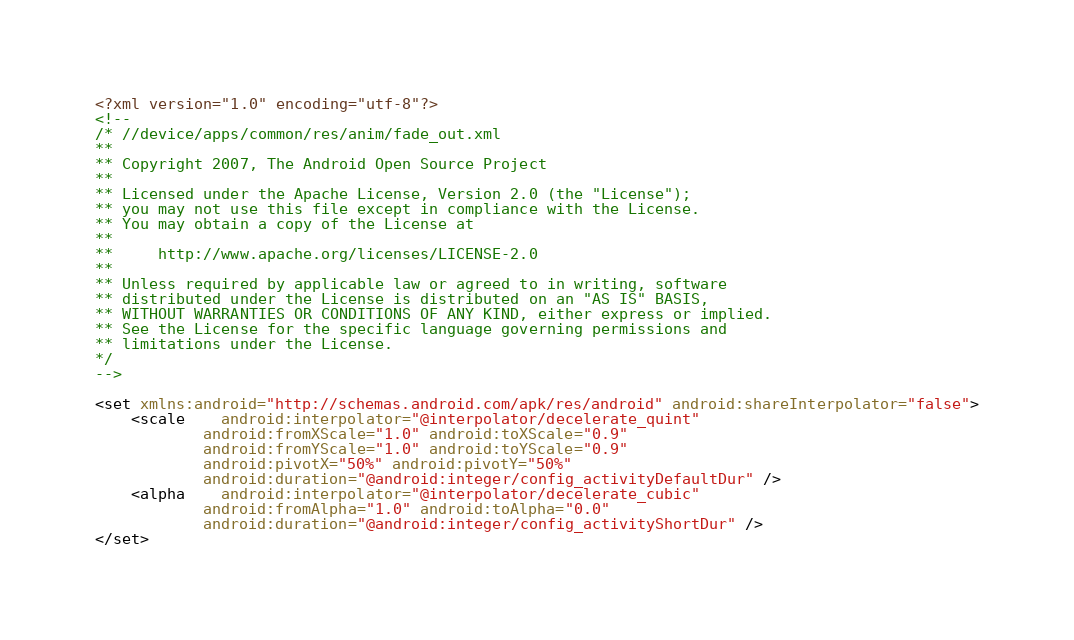Convert code to text. <code><loc_0><loc_0><loc_500><loc_500><_XML_><?xml version="1.0" encoding="utf-8"?>
<!--
/* //device/apps/common/res/anim/fade_out.xml
**
** Copyright 2007, The Android Open Source Project
**
** Licensed under the Apache License, Version 2.0 (the "License"); 
** you may not use this file except in compliance with the License. 
** You may obtain a copy of the License at 
**
**     http://www.apache.org/licenses/LICENSE-2.0 
**
** Unless required by applicable law or agreed to in writing, software 
** distributed under the License is distributed on an "AS IS" BASIS, 
** WITHOUT WARRANTIES OR CONDITIONS OF ANY KIND, either express or implied. 
** See the License for the specific language governing permissions and 
** limitations under the License.
*/
-->

<set xmlns:android="http://schemas.android.com/apk/res/android" android:shareInterpolator="false">
    <scale 	android:interpolator="@interpolator/decelerate_quint"
	    	android:fromXScale="1.0" android:toXScale="0.9"
	        android:fromYScale="1.0" android:toYScale="0.9"
           	android:pivotX="50%" android:pivotY="50%"
           	android:duration="@android:integer/config_activityDefaultDur" />
    <alpha 	android:interpolator="@interpolator/decelerate_cubic"
            android:fromAlpha="1.0" android:toAlpha="0.0"
            android:duration="@android:integer/config_activityShortDur" />
</set></code> 